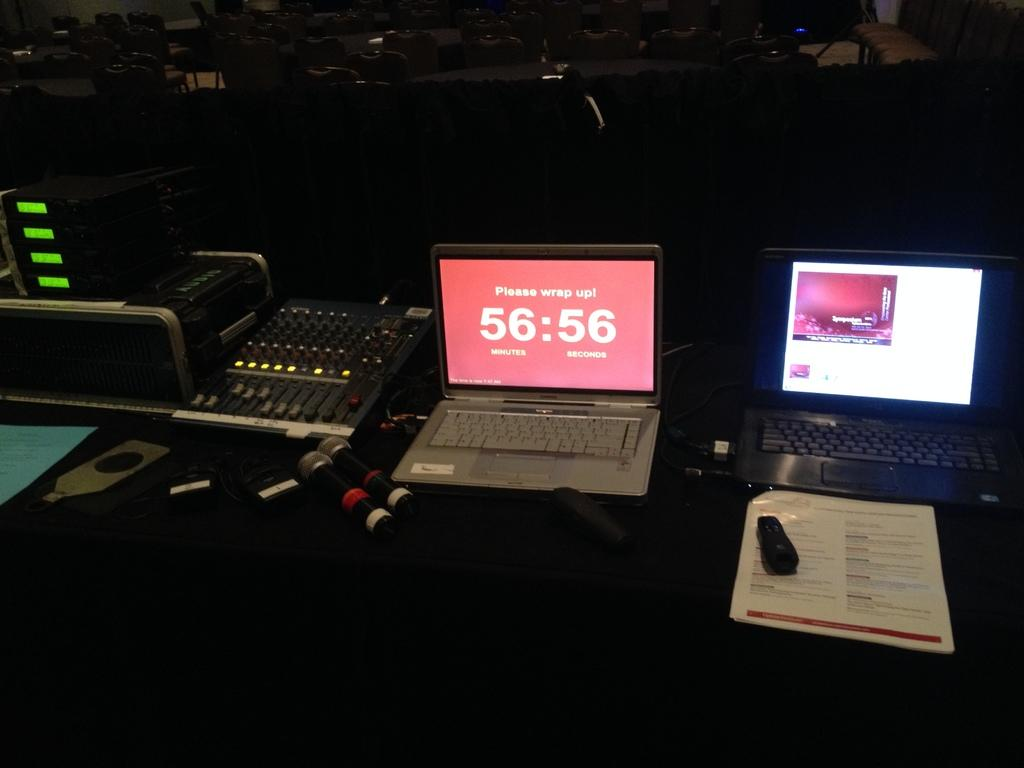<image>
Relay a brief, clear account of the picture shown. A laptop computer screen shows a timer and the words, please wrap up. 